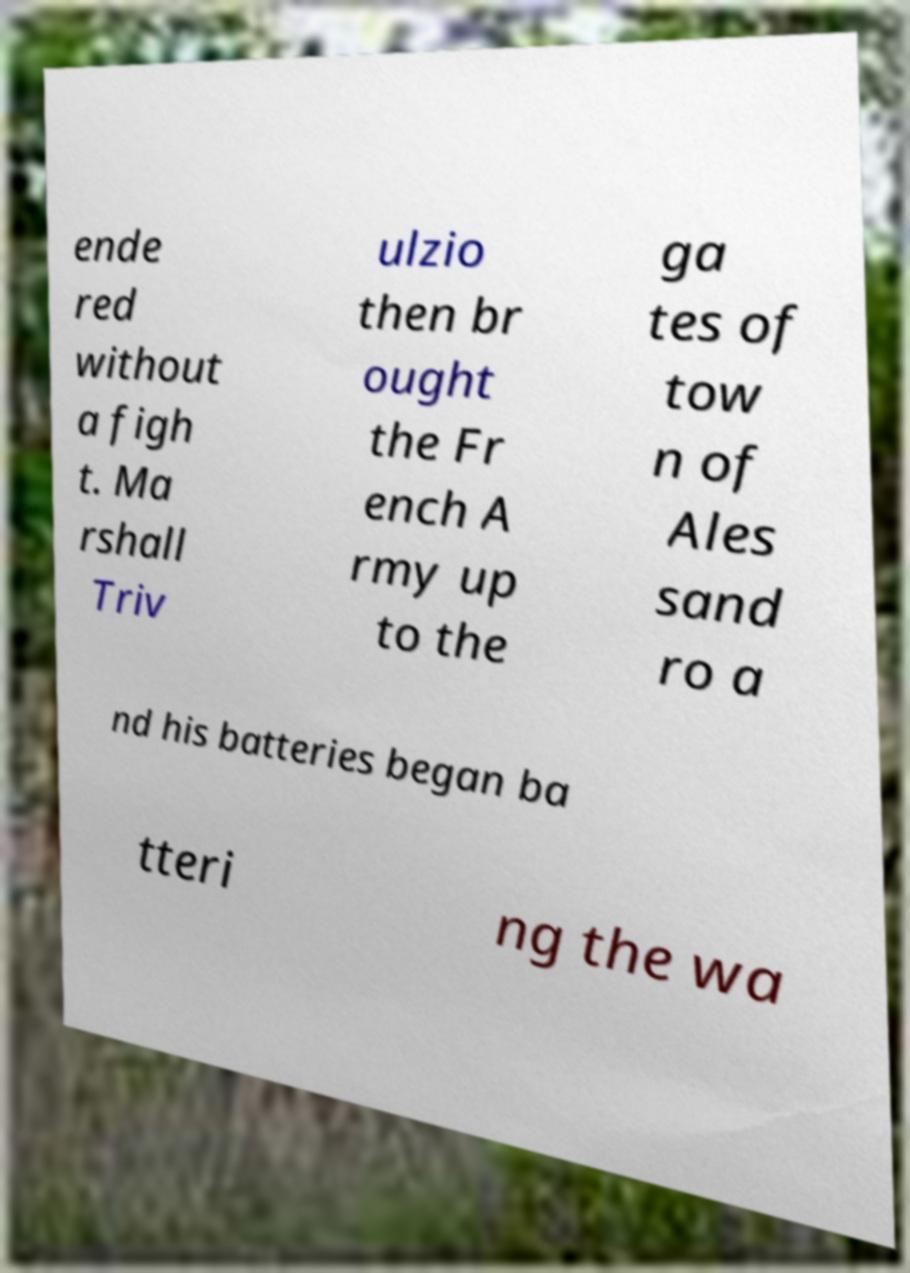Can you accurately transcribe the text from the provided image for me? ende red without a figh t. Ma rshall Triv ulzio then br ought the Fr ench A rmy up to the ga tes of tow n of Ales sand ro a nd his batteries began ba tteri ng the wa 